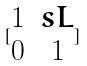Convert formula to latex. <formula><loc_0><loc_0><loc_500><loc_500>[ \begin{matrix} 1 & s L \\ 0 & 1 \end{matrix} ]</formula> 